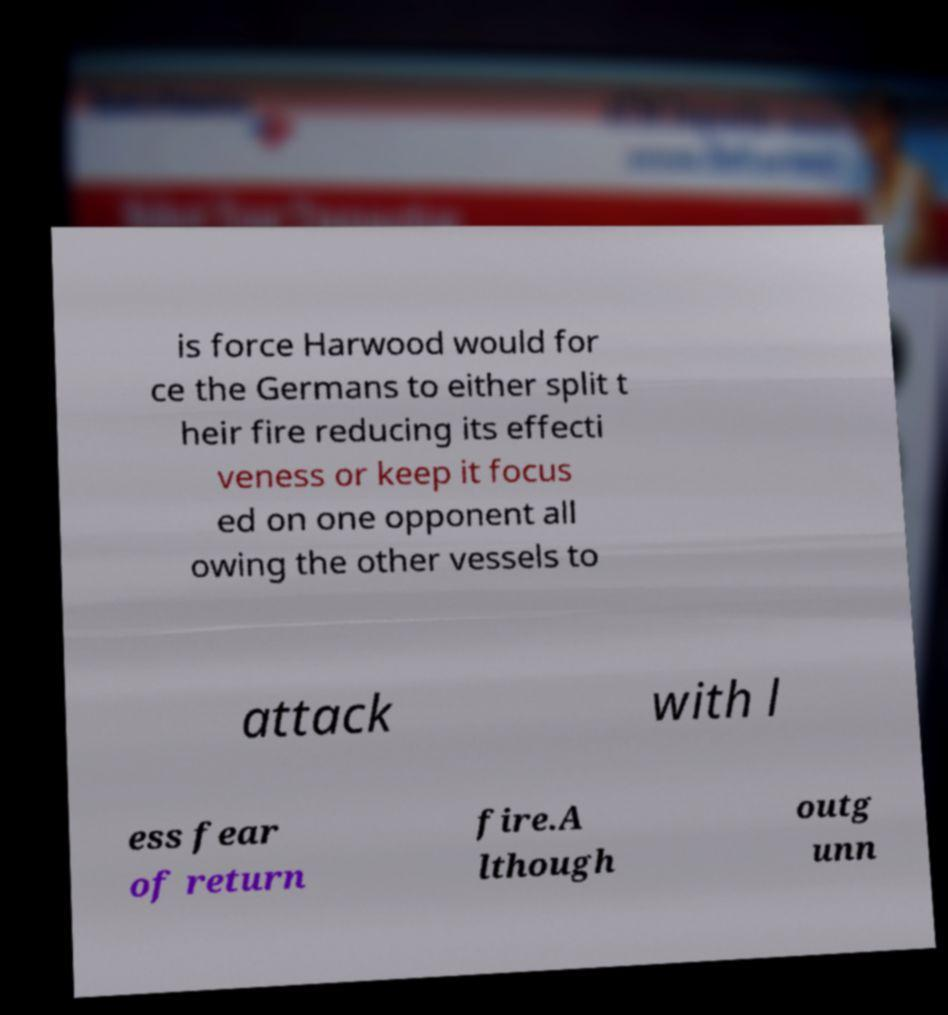For documentation purposes, I need the text within this image transcribed. Could you provide that? is force Harwood would for ce the Germans to either split t heir fire reducing its effecti veness or keep it focus ed on one opponent all owing the other vessels to attack with l ess fear of return fire.A lthough outg unn 